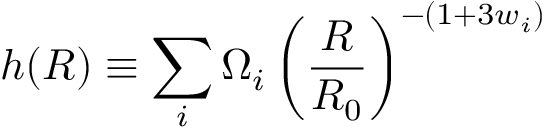Convert formula to latex. <formula><loc_0><loc_0><loc_500><loc_500>h ( R ) \equiv \sum _ { i } \Omega _ { i } \left ( \frac { R } { R _ { 0 } } \right ) ^ { - ( 1 + 3 w _ { i } ) }</formula> 